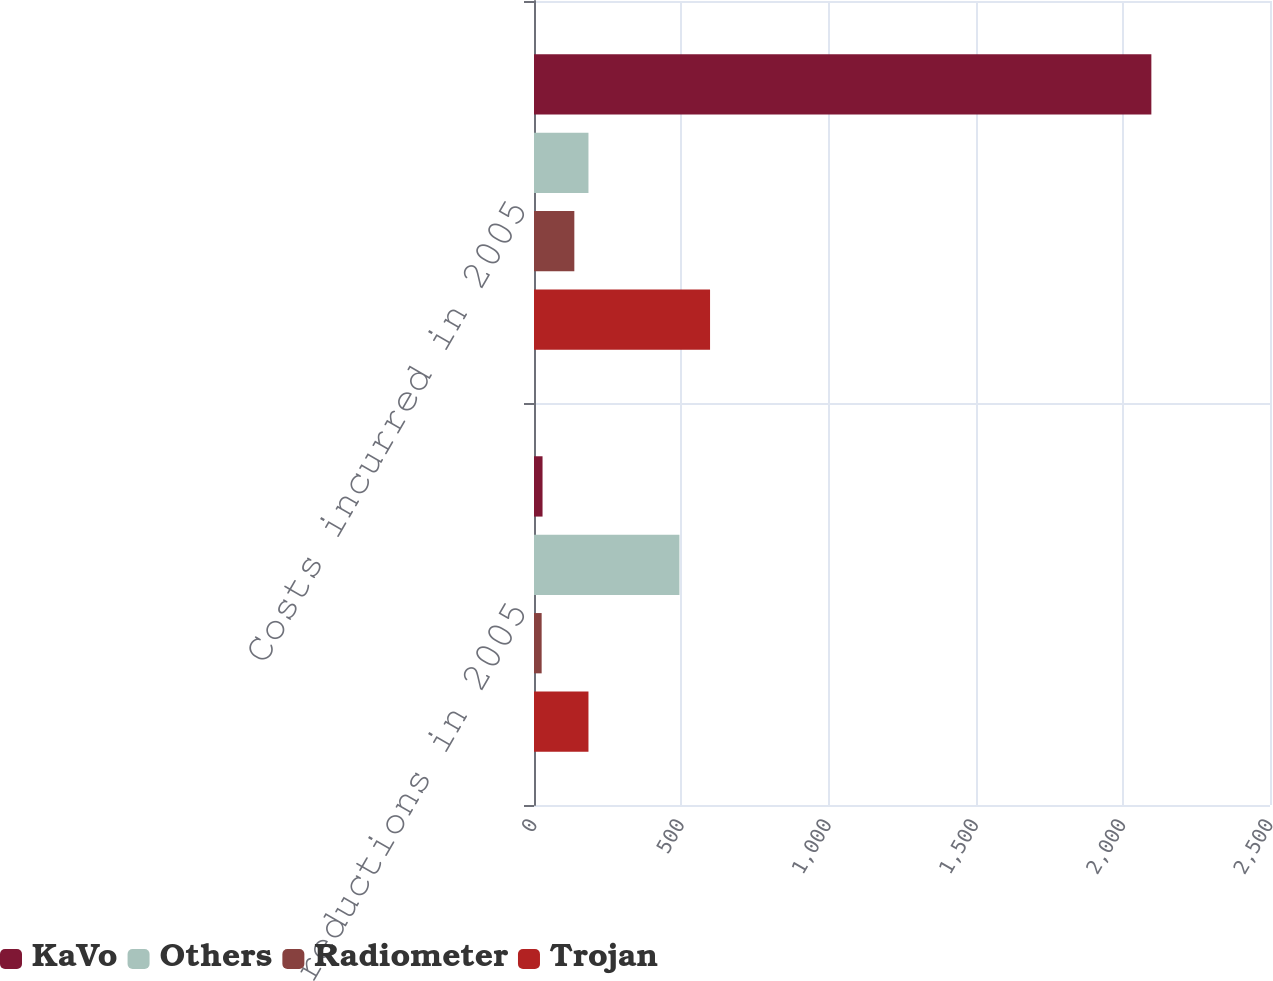Convert chart. <chart><loc_0><loc_0><loc_500><loc_500><stacked_bar_chart><ecel><fcel>Headcount reductions in 2005<fcel>Costs incurred in 2005<nl><fcel>KaVo<fcel>29<fcel>2097<nl><fcel>Others<fcel>494<fcel>185<nl><fcel>Radiometer<fcel>26<fcel>137<nl><fcel>Trojan<fcel>185<fcel>598<nl></chart> 